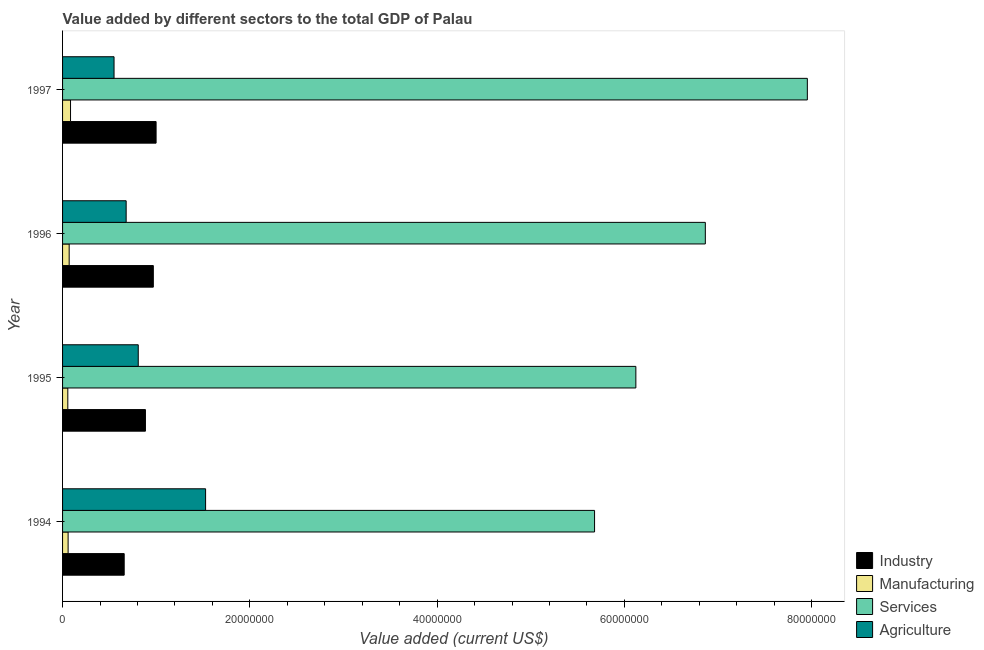How many groups of bars are there?
Keep it short and to the point. 4. Are the number of bars per tick equal to the number of legend labels?
Keep it short and to the point. Yes. Are the number of bars on each tick of the Y-axis equal?
Your answer should be very brief. Yes. How many bars are there on the 2nd tick from the top?
Ensure brevity in your answer.  4. What is the label of the 3rd group of bars from the top?
Offer a terse response. 1995. In how many cases, is the number of bars for a given year not equal to the number of legend labels?
Provide a succinct answer. 0. What is the value added by industrial sector in 1997?
Keep it short and to the point. 9.99e+06. Across all years, what is the maximum value added by services sector?
Ensure brevity in your answer.  7.95e+07. Across all years, what is the minimum value added by industrial sector?
Your answer should be very brief. 6.58e+06. In which year was the value added by industrial sector maximum?
Ensure brevity in your answer.  1997. In which year was the value added by industrial sector minimum?
Offer a very short reply. 1994. What is the total value added by industrial sector in the graph?
Make the answer very short. 3.51e+07. What is the difference between the value added by agricultural sector in 1995 and that in 1997?
Make the answer very short. 2.58e+06. What is the difference between the value added by agricultural sector in 1994 and the value added by manufacturing sector in 1995?
Your answer should be very brief. 1.47e+07. What is the average value added by services sector per year?
Ensure brevity in your answer.  6.65e+07. In the year 1995, what is the difference between the value added by industrial sector and value added by services sector?
Make the answer very short. -5.24e+07. What is the ratio of the value added by agricultural sector in 1995 to that in 1996?
Give a very brief answer. 1.19. Is the difference between the value added by industrial sector in 1995 and 1996 greater than the difference between the value added by agricultural sector in 1995 and 1996?
Ensure brevity in your answer.  No. What is the difference between the highest and the second highest value added by industrial sector?
Provide a succinct answer. 2.95e+05. What is the difference between the highest and the lowest value added by industrial sector?
Your answer should be very brief. 3.41e+06. What does the 1st bar from the top in 1997 represents?
Your response must be concise. Agriculture. What does the 4th bar from the bottom in 1996 represents?
Your response must be concise. Agriculture. Is it the case that in every year, the sum of the value added by industrial sector and value added by manufacturing sector is greater than the value added by services sector?
Provide a succinct answer. No. How many bars are there?
Your answer should be compact. 16. Are the values on the major ticks of X-axis written in scientific E-notation?
Make the answer very short. No. How are the legend labels stacked?
Your answer should be compact. Vertical. What is the title of the graph?
Keep it short and to the point. Value added by different sectors to the total GDP of Palau. Does "Public sector management" appear as one of the legend labels in the graph?
Provide a short and direct response. No. What is the label or title of the X-axis?
Keep it short and to the point. Value added (current US$). What is the label or title of the Y-axis?
Keep it short and to the point. Year. What is the Value added (current US$) in Industry in 1994?
Offer a terse response. 6.58e+06. What is the Value added (current US$) in Manufacturing in 1994?
Provide a short and direct response. 5.92e+05. What is the Value added (current US$) of Services in 1994?
Provide a short and direct response. 5.68e+07. What is the Value added (current US$) of Agriculture in 1994?
Offer a terse response. 1.53e+07. What is the Value added (current US$) of Industry in 1995?
Your response must be concise. 8.85e+06. What is the Value added (current US$) in Manufacturing in 1995?
Your response must be concise. 5.60e+05. What is the Value added (current US$) in Services in 1995?
Offer a terse response. 6.12e+07. What is the Value added (current US$) of Agriculture in 1995?
Your answer should be very brief. 8.08e+06. What is the Value added (current US$) of Industry in 1996?
Provide a succinct answer. 9.69e+06. What is the Value added (current US$) of Manufacturing in 1996?
Provide a succinct answer. 7.05e+05. What is the Value added (current US$) of Services in 1996?
Keep it short and to the point. 6.86e+07. What is the Value added (current US$) of Agriculture in 1996?
Provide a short and direct response. 6.79e+06. What is the Value added (current US$) in Industry in 1997?
Your response must be concise. 9.99e+06. What is the Value added (current US$) in Manufacturing in 1997?
Your response must be concise. 8.51e+05. What is the Value added (current US$) in Services in 1997?
Your answer should be very brief. 7.95e+07. What is the Value added (current US$) of Agriculture in 1997?
Your answer should be very brief. 5.50e+06. Across all years, what is the maximum Value added (current US$) in Industry?
Your answer should be very brief. 9.99e+06. Across all years, what is the maximum Value added (current US$) of Manufacturing?
Keep it short and to the point. 8.51e+05. Across all years, what is the maximum Value added (current US$) in Services?
Your response must be concise. 7.95e+07. Across all years, what is the maximum Value added (current US$) of Agriculture?
Your answer should be compact. 1.53e+07. Across all years, what is the minimum Value added (current US$) in Industry?
Provide a short and direct response. 6.58e+06. Across all years, what is the minimum Value added (current US$) of Manufacturing?
Offer a very short reply. 5.60e+05. Across all years, what is the minimum Value added (current US$) in Services?
Provide a short and direct response. 5.68e+07. Across all years, what is the minimum Value added (current US$) of Agriculture?
Provide a short and direct response. 5.50e+06. What is the total Value added (current US$) in Industry in the graph?
Offer a terse response. 3.51e+07. What is the total Value added (current US$) in Manufacturing in the graph?
Give a very brief answer. 2.71e+06. What is the total Value added (current US$) of Services in the graph?
Offer a terse response. 2.66e+08. What is the total Value added (current US$) in Agriculture in the graph?
Give a very brief answer. 3.56e+07. What is the difference between the Value added (current US$) in Industry in 1994 and that in 1995?
Your response must be concise. -2.27e+06. What is the difference between the Value added (current US$) of Manufacturing in 1994 and that in 1995?
Your answer should be compact. 3.20e+04. What is the difference between the Value added (current US$) in Services in 1994 and that in 1995?
Keep it short and to the point. -4.41e+06. What is the difference between the Value added (current US$) of Agriculture in 1994 and that in 1995?
Make the answer very short. 7.19e+06. What is the difference between the Value added (current US$) in Industry in 1994 and that in 1996?
Keep it short and to the point. -3.11e+06. What is the difference between the Value added (current US$) of Manufacturing in 1994 and that in 1996?
Provide a short and direct response. -1.13e+05. What is the difference between the Value added (current US$) of Services in 1994 and that in 1996?
Offer a terse response. -1.18e+07. What is the difference between the Value added (current US$) of Agriculture in 1994 and that in 1996?
Make the answer very short. 8.48e+06. What is the difference between the Value added (current US$) in Industry in 1994 and that in 1997?
Keep it short and to the point. -3.41e+06. What is the difference between the Value added (current US$) of Manufacturing in 1994 and that in 1997?
Offer a terse response. -2.59e+05. What is the difference between the Value added (current US$) in Services in 1994 and that in 1997?
Provide a succinct answer. -2.27e+07. What is the difference between the Value added (current US$) in Agriculture in 1994 and that in 1997?
Offer a very short reply. 9.78e+06. What is the difference between the Value added (current US$) in Industry in 1995 and that in 1996?
Offer a very short reply. -8.42e+05. What is the difference between the Value added (current US$) of Manufacturing in 1995 and that in 1996?
Your response must be concise. -1.45e+05. What is the difference between the Value added (current US$) in Services in 1995 and that in 1996?
Your answer should be compact. -7.42e+06. What is the difference between the Value added (current US$) of Agriculture in 1995 and that in 1996?
Provide a short and direct response. 1.29e+06. What is the difference between the Value added (current US$) in Industry in 1995 and that in 1997?
Keep it short and to the point. -1.14e+06. What is the difference between the Value added (current US$) in Manufacturing in 1995 and that in 1997?
Make the answer very short. -2.91e+05. What is the difference between the Value added (current US$) of Services in 1995 and that in 1997?
Provide a short and direct response. -1.83e+07. What is the difference between the Value added (current US$) in Agriculture in 1995 and that in 1997?
Your response must be concise. 2.58e+06. What is the difference between the Value added (current US$) in Industry in 1996 and that in 1997?
Your answer should be very brief. -2.95e+05. What is the difference between the Value added (current US$) in Manufacturing in 1996 and that in 1997?
Your answer should be compact. -1.46e+05. What is the difference between the Value added (current US$) in Services in 1996 and that in 1997?
Your answer should be very brief. -1.09e+07. What is the difference between the Value added (current US$) in Agriculture in 1996 and that in 1997?
Your answer should be compact. 1.29e+06. What is the difference between the Value added (current US$) in Industry in 1994 and the Value added (current US$) in Manufacturing in 1995?
Make the answer very short. 6.02e+06. What is the difference between the Value added (current US$) in Industry in 1994 and the Value added (current US$) in Services in 1995?
Provide a succinct answer. -5.46e+07. What is the difference between the Value added (current US$) of Industry in 1994 and the Value added (current US$) of Agriculture in 1995?
Provide a short and direct response. -1.50e+06. What is the difference between the Value added (current US$) in Manufacturing in 1994 and the Value added (current US$) in Services in 1995?
Ensure brevity in your answer.  -6.06e+07. What is the difference between the Value added (current US$) of Manufacturing in 1994 and the Value added (current US$) of Agriculture in 1995?
Your answer should be very brief. -7.49e+06. What is the difference between the Value added (current US$) of Services in 1994 and the Value added (current US$) of Agriculture in 1995?
Provide a succinct answer. 4.87e+07. What is the difference between the Value added (current US$) in Industry in 1994 and the Value added (current US$) in Manufacturing in 1996?
Your answer should be compact. 5.88e+06. What is the difference between the Value added (current US$) of Industry in 1994 and the Value added (current US$) of Services in 1996?
Provide a succinct answer. -6.21e+07. What is the difference between the Value added (current US$) of Industry in 1994 and the Value added (current US$) of Agriculture in 1996?
Offer a terse response. -2.09e+05. What is the difference between the Value added (current US$) in Manufacturing in 1994 and the Value added (current US$) in Services in 1996?
Your answer should be very brief. -6.80e+07. What is the difference between the Value added (current US$) of Manufacturing in 1994 and the Value added (current US$) of Agriculture in 1996?
Your answer should be compact. -6.20e+06. What is the difference between the Value added (current US$) of Services in 1994 and the Value added (current US$) of Agriculture in 1996?
Provide a short and direct response. 5.00e+07. What is the difference between the Value added (current US$) in Industry in 1994 and the Value added (current US$) in Manufacturing in 1997?
Provide a short and direct response. 5.73e+06. What is the difference between the Value added (current US$) in Industry in 1994 and the Value added (current US$) in Services in 1997?
Ensure brevity in your answer.  -7.30e+07. What is the difference between the Value added (current US$) in Industry in 1994 and the Value added (current US$) in Agriculture in 1997?
Offer a very short reply. 1.08e+06. What is the difference between the Value added (current US$) in Manufacturing in 1994 and the Value added (current US$) in Services in 1997?
Offer a very short reply. -7.89e+07. What is the difference between the Value added (current US$) of Manufacturing in 1994 and the Value added (current US$) of Agriculture in 1997?
Give a very brief answer. -4.90e+06. What is the difference between the Value added (current US$) in Services in 1994 and the Value added (current US$) in Agriculture in 1997?
Your answer should be very brief. 5.13e+07. What is the difference between the Value added (current US$) in Industry in 1995 and the Value added (current US$) in Manufacturing in 1996?
Keep it short and to the point. 8.14e+06. What is the difference between the Value added (current US$) in Industry in 1995 and the Value added (current US$) in Services in 1996?
Offer a very short reply. -5.98e+07. What is the difference between the Value added (current US$) of Industry in 1995 and the Value added (current US$) of Agriculture in 1996?
Ensure brevity in your answer.  2.06e+06. What is the difference between the Value added (current US$) of Manufacturing in 1995 and the Value added (current US$) of Services in 1996?
Ensure brevity in your answer.  -6.81e+07. What is the difference between the Value added (current US$) of Manufacturing in 1995 and the Value added (current US$) of Agriculture in 1996?
Offer a terse response. -6.23e+06. What is the difference between the Value added (current US$) of Services in 1995 and the Value added (current US$) of Agriculture in 1996?
Ensure brevity in your answer.  5.44e+07. What is the difference between the Value added (current US$) of Industry in 1995 and the Value added (current US$) of Manufacturing in 1997?
Offer a terse response. 8.00e+06. What is the difference between the Value added (current US$) in Industry in 1995 and the Value added (current US$) in Services in 1997?
Give a very brief answer. -7.07e+07. What is the difference between the Value added (current US$) in Industry in 1995 and the Value added (current US$) in Agriculture in 1997?
Provide a succinct answer. 3.35e+06. What is the difference between the Value added (current US$) in Manufacturing in 1995 and the Value added (current US$) in Services in 1997?
Ensure brevity in your answer.  -7.90e+07. What is the difference between the Value added (current US$) of Manufacturing in 1995 and the Value added (current US$) of Agriculture in 1997?
Provide a short and direct response. -4.94e+06. What is the difference between the Value added (current US$) of Services in 1995 and the Value added (current US$) of Agriculture in 1997?
Provide a succinct answer. 5.57e+07. What is the difference between the Value added (current US$) of Industry in 1996 and the Value added (current US$) of Manufacturing in 1997?
Ensure brevity in your answer.  8.84e+06. What is the difference between the Value added (current US$) of Industry in 1996 and the Value added (current US$) of Services in 1997?
Make the answer very short. -6.98e+07. What is the difference between the Value added (current US$) in Industry in 1996 and the Value added (current US$) in Agriculture in 1997?
Your answer should be very brief. 4.20e+06. What is the difference between the Value added (current US$) of Manufacturing in 1996 and the Value added (current US$) of Services in 1997?
Offer a very short reply. -7.88e+07. What is the difference between the Value added (current US$) in Manufacturing in 1996 and the Value added (current US$) in Agriculture in 1997?
Offer a very short reply. -4.79e+06. What is the difference between the Value added (current US$) of Services in 1996 and the Value added (current US$) of Agriculture in 1997?
Ensure brevity in your answer.  6.31e+07. What is the average Value added (current US$) of Industry per year?
Your answer should be compact. 8.78e+06. What is the average Value added (current US$) in Manufacturing per year?
Provide a short and direct response. 6.77e+05. What is the average Value added (current US$) of Services per year?
Offer a very short reply. 6.65e+07. What is the average Value added (current US$) of Agriculture per year?
Provide a short and direct response. 8.91e+06. In the year 1994, what is the difference between the Value added (current US$) in Industry and Value added (current US$) in Manufacturing?
Your answer should be very brief. 5.99e+06. In the year 1994, what is the difference between the Value added (current US$) of Industry and Value added (current US$) of Services?
Keep it short and to the point. -5.02e+07. In the year 1994, what is the difference between the Value added (current US$) in Industry and Value added (current US$) in Agriculture?
Give a very brief answer. -8.69e+06. In the year 1994, what is the difference between the Value added (current US$) in Manufacturing and Value added (current US$) in Services?
Your response must be concise. -5.62e+07. In the year 1994, what is the difference between the Value added (current US$) of Manufacturing and Value added (current US$) of Agriculture?
Offer a terse response. -1.47e+07. In the year 1994, what is the difference between the Value added (current US$) in Services and Value added (current US$) in Agriculture?
Make the answer very short. 4.15e+07. In the year 1995, what is the difference between the Value added (current US$) of Industry and Value added (current US$) of Manufacturing?
Your answer should be compact. 8.29e+06. In the year 1995, what is the difference between the Value added (current US$) of Industry and Value added (current US$) of Services?
Offer a terse response. -5.24e+07. In the year 1995, what is the difference between the Value added (current US$) of Industry and Value added (current US$) of Agriculture?
Your answer should be very brief. 7.68e+05. In the year 1995, what is the difference between the Value added (current US$) in Manufacturing and Value added (current US$) in Services?
Your response must be concise. -6.07e+07. In the year 1995, what is the difference between the Value added (current US$) of Manufacturing and Value added (current US$) of Agriculture?
Keep it short and to the point. -7.52e+06. In the year 1995, what is the difference between the Value added (current US$) of Services and Value added (current US$) of Agriculture?
Provide a succinct answer. 5.31e+07. In the year 1996, what is the difference between the Value added (current US$) in Industry and Value added (current US$) in Manufacturing?
Your response must be concise. 8.99e+06. In the year 1996, what is the difference between the Value added (current US$) in Industry and Value added (current US$) in Services?
Your answer should be compact. -5.89e+07. In the year 1996, what is the difference between the Value added (current US$) in Industry and Value added (current US$) in Agriculture?
Make the answer very short. 2.90e+06. In the year 1996, what is the difference between the Value added (current US$) in Manufacturing and Value added (current US$) in Services?
Make the answer very short. -6.79e+07. In the year 1996, what is the difference between the Value added (current US$) in Manufacturing and Value added (current US$) in Agriculture?
Offer a terse response. -6.08e+06. In the year 1996, what is the difference between the Value added (current US$) of Services and Value added (current US$) of Agriculture?
Give a very brief answer. 6.18e+07. In the year 1997, what is the difference between the Value added (current US$) in Industry and Value added (current US$) in Manufacturing?
Your response must be concise. 9.14e+06. In the year 1997, what is the difference between the Value added (current US$) of Industry and Value added (current US$) of Services?
Offer a terse response. -6.95e+07. In the year 1997, what is the difference between the Value added (current US$) of Industry and Value added (current US$) of Agriculture?
Give a very brief answer. 4.49e+06. In the year 1997, what is the difference between the Value added (current US$) of Manufacturing and Value added (current US$) of Services?
Keep it short and to the point. -7.87e+07. In the year 1997, what is the difference between the Value added (current US$) of Manufacturing and Value added (current US$) of Agriculture?
Your answer should be compact. -4.65e+06. In the year 1997, what is the difference between the Value added (current US$) in Services and Value added (current US$) in Agriculture?
Provide a short and direct response. 7.40e+07. What is the ratio of the Value added (current US$) of Industry in 1994 to that in 1995?
Make the answer very short. 0.74. What is the ratio of the Value added (current US$) in Manufacturing in 1994 to that in 1995?
Your answer should be compact. 1.06. What is the ratio of the Value added (current US$) of Services in 1994 to that in 1995?
Keep it short and to the point. 0.93. What is the ratio of the Value added (current US$) in Agriculture in 1994 to that in 1995?
Provide a short and direct response. 1.89. What is the ratio of the Value added (current US$) in Industry in 1994 to that in 1996?
Make the answer very short. 0.68. What is the ratio of the Value added (current US$) in Manufacturing in 1994 to that in 1996?
Provide a short and direct response. 0.84. What is the ratio of the Value added (current US$) in Services in 1994 to that in 1996?
Provide a short and direct response. 0.83. What is the ratio of the Value added (current US$) in Agriculture in 1994 to that in 1996?
Give a very brief answer. 2.25. What is the ratio of the Value added (current US$) of Industry in 1994 to that in 1997?
Your answer should be compact. 0.66. What is the ratio of the Value added (current US$) of Manufacturing in 1994 to that in 1997?
Make the answer very short. 0.7. What is the ratio of the Value added (current US$) of Agriculture in 1994 to that in 1997?
Offer a very short reply. 2.78. What is the ratio of the Value added (current US$) of Industry in 1995 to that in 1996?
Keep it short and to the point. 0.91. What is the ratio of the Value added (current US$) in Manufacturing in 1995 to that in 1996?
Your answer should be compact. 0.79. What is the ratio of the Value added (current US$) of Services in 1995 to that in 1996?
Offer a terse response. 0.89. What is the ratio of the Value added (current US$) of Agriculture in 1995 to that in 1996?
Offer a terse response. 1.19. What is the ratio of the Value added (current US$) in Industry in 1995 to that in 1997?
Keep it short and to the point. 0.89. What is the ratio of the Value added (current US$) in Manufacturing in 1995 to that in 1997?
Keep it short and to the point. 0.66. What is the ratio of the Value added (current US$) in Services in 1995 to that in 1997?
Offer a terse response. 0.77. What is the ratio of the Value added (current US$) of Agriculture in 1995 to that in 1997?
Provide a succinct answer. 1.47. What is the ratio of the Value added (current US$) of Industry in 1996 to that in 1997?
Offer a very short reply. 0.97. What is the ratio of the Value added (current US$) of Manufacturing in 1996 to that in 1997?
Provide a succinct answer. 0.83. What is the ratio of the Value added (current US$) in Services in 1996 to that in 1997?
Offer a terse response. 0.86. What is the ratio of the Value added (current US$) of Agriculture in 1996 to that in 1997?
Keep it short and to the point. 1.24. What is the difference between the highest and the second highest Value added (current US$) of Industry?
Ensure brevity in your answer.  2.95e+05. What is the difference between the highest and the second highest Value added (current US$) in Manufacturing?
Offer a terse response. 1.46e+05. What is the difference between the highest and the second highest Value added (current US$) in Services?
Give a very brief answer. 1.09e+07. What is the difference between the highest and the second highest Value added (current US$) in Agriculture?
Your response must be concise. 7.19e+06. What is the difference between the highest and the lowest Value added (current US$) in Industry?
Your response must be concise. 3.41e+06. What is the difference between the highest and the lowest Value added (current US$) of Manufacturing?
Offer a very short reply. 2.91e+05. What is the difference between the highest and the lowest Value added (current US$) of Services?
Provide a short and direct response. 2.27e+07. What is the difference between the highest and the lowest Value added (current US$) in Agriculture?
Your answer should be very brief. 9.78e+06. 